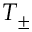<formula> <loc_0><loc_0><loc_500><loc_500>T _ { \pm }</formula> 